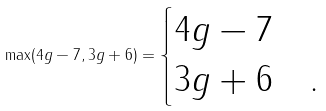<formula> <loc_0><loc_0><loc_500><loc_500>\max ( 4 g - 7 , 3 g + 6 ) = \begin{cases} 4 g - 7 & \\ 3 g + 6 & . \end{cases}</formula> 